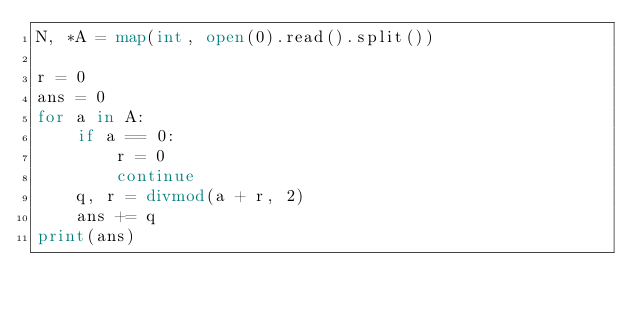Convert code to text. <code><loc_0><loc_0><loc_500><loc_500><_Python_>N, *A = map(int, open(0).read().split())

r = 0
ans = 0
for a in A:
    if a == 0:
        r = 0
        continue
    q, r = divmod(a + r, 2)
    ans += q
print(ans)
</code> 